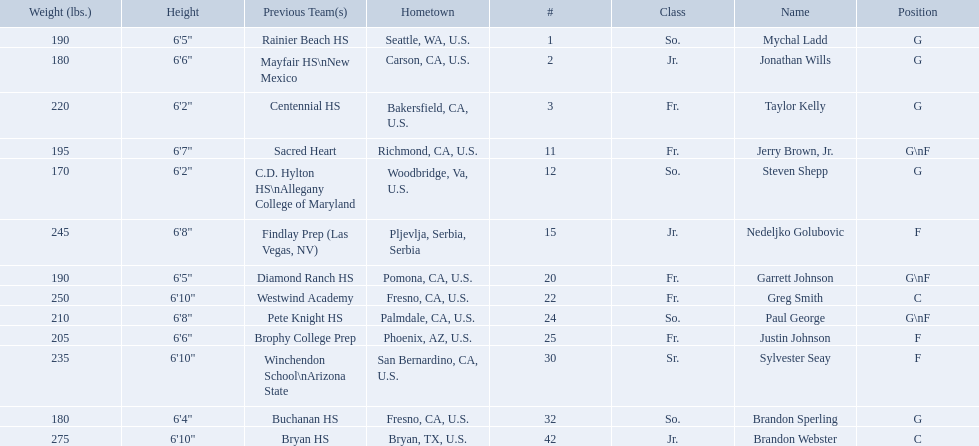Who are all of the players? Mychal Ladd, Jonathan Wills, Taylor Kelly, Jerry Brown, Jr., Steven Shepp, Nedeljko Golubovic, Garrett Johnson, Greg Smith, Paul George, Justin Johnson, Sylvester Seay, Brandon Sperling, Brandon Webster. What are their heights? 6'5", 6'6", 6'2", 6'7", 6'2", 6'8", 6'5", 6'10", 6'8", 6'6", 6'10", 6'4", 6'10". Along with taylor kelly, which other player is shorter than 6'3? Steven Shepp. What are the listed classes of the players? So., Jr., Fr., Fr., So., Jr., Fr., Fr., So., Fr., Sr., So., Jr. Which of these is not from the us? Jr. To which name does that entry correspond to? Nedeljko Golubovic. 